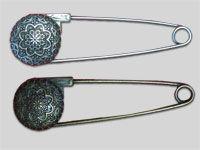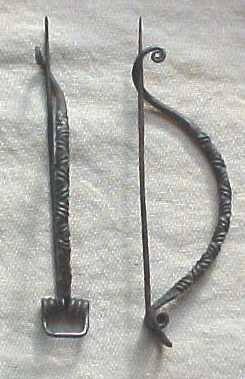The first image is the image on the left, the second image is the image on the right. Evaluate the accuracy of this statement regarding the images: "The two pins in the image on the left are not touching each other.". Is it true? Answer yes or no. Yes. The first image is the image on the left, the second image is the image on the right. Evaluate the accuracy of this statement regarding the images: "An image contains exactly two safety pins, displayed one above the other, and not overlapping.". Is it true? Answer yes or no. Yes. 